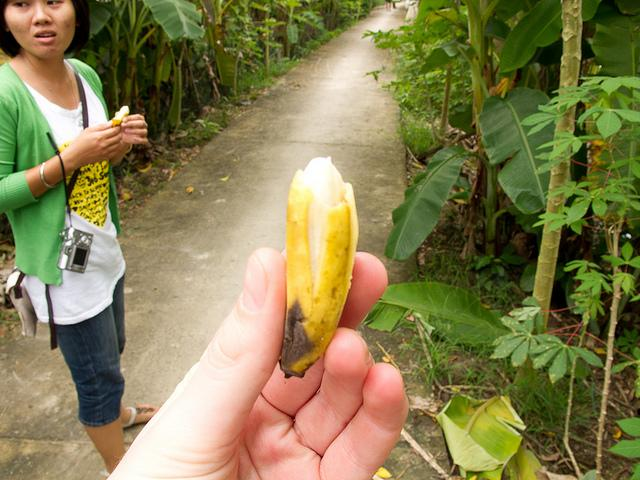The woman eating the fruit is likely on the path for what reason?

Choices:
A) surveying
B) tourism
C) assisting
D) commuting tourism 